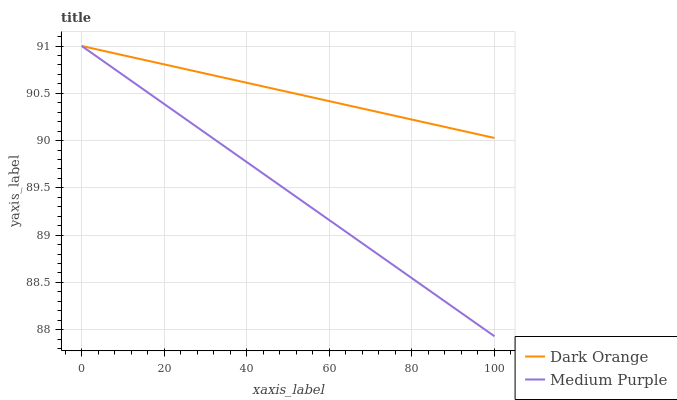Does Dark Orange have the minimum area under the curve?
Answer yes or no. No. Is Dark Orange the roughest?
Answer yes or no. No. Does Dark Orange have the lowest value?
Answer yes or no. No. 